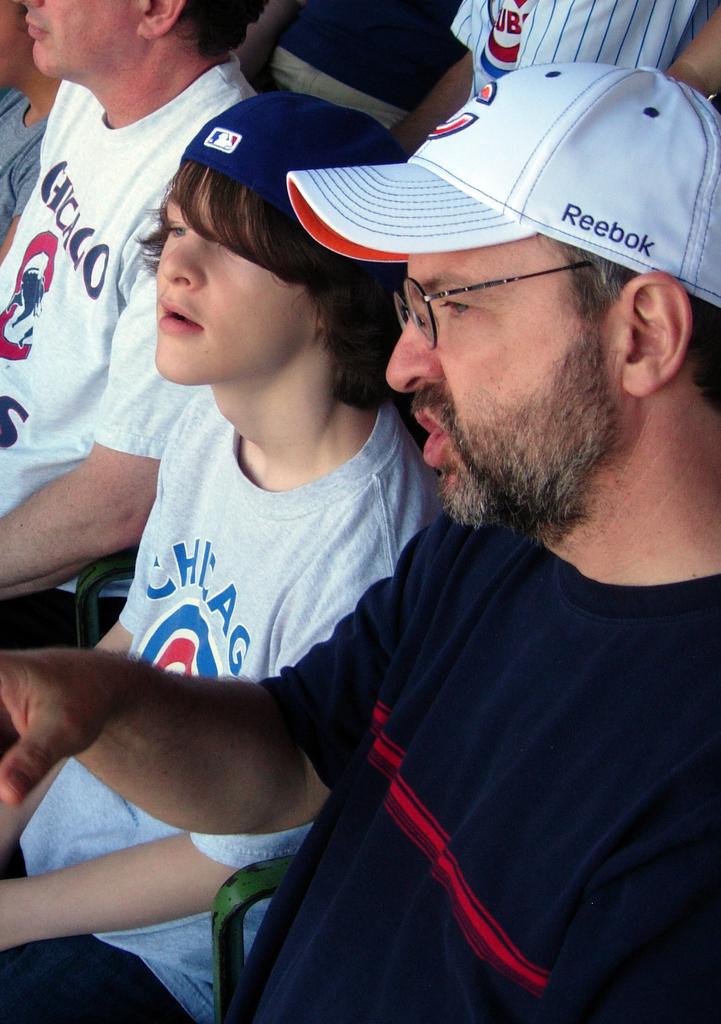What company makes the dad's baseball hat?
Keep it short and to the point. Reebok. Which team is on the shirt?
Keep it short and to the point. Chicago cubs. 